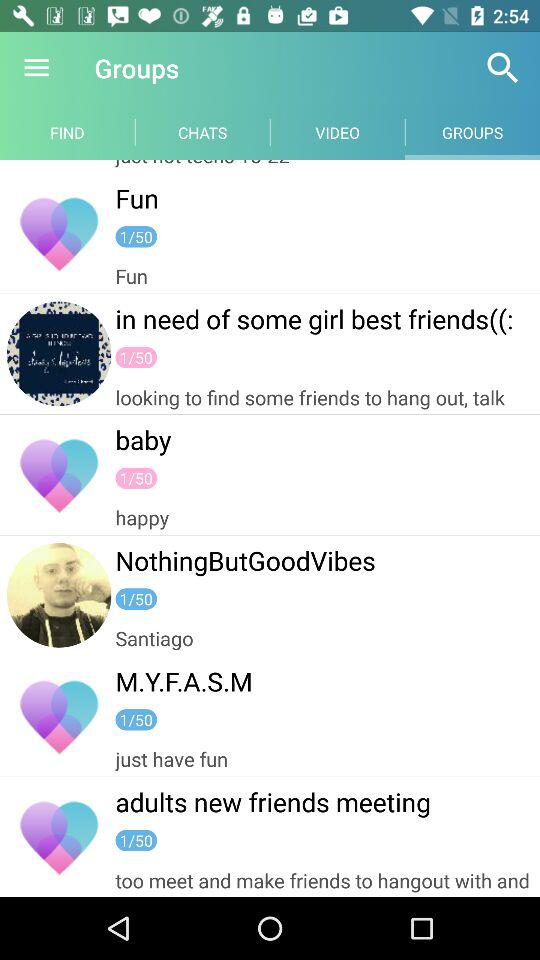Which tab is currently selected? The tab "GROUPS" is currently selected. 